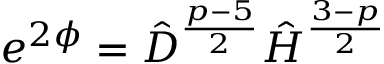Convert formula to latex. <formula><loc_0><loc_0><loc_500><loc_500>e ^ { 2 \phi } = \hat { D } ^ { \frac { p - 5 } { 2 } } \hat { H } ^ { \frac { 3 - p } { 2 } }</formula> 